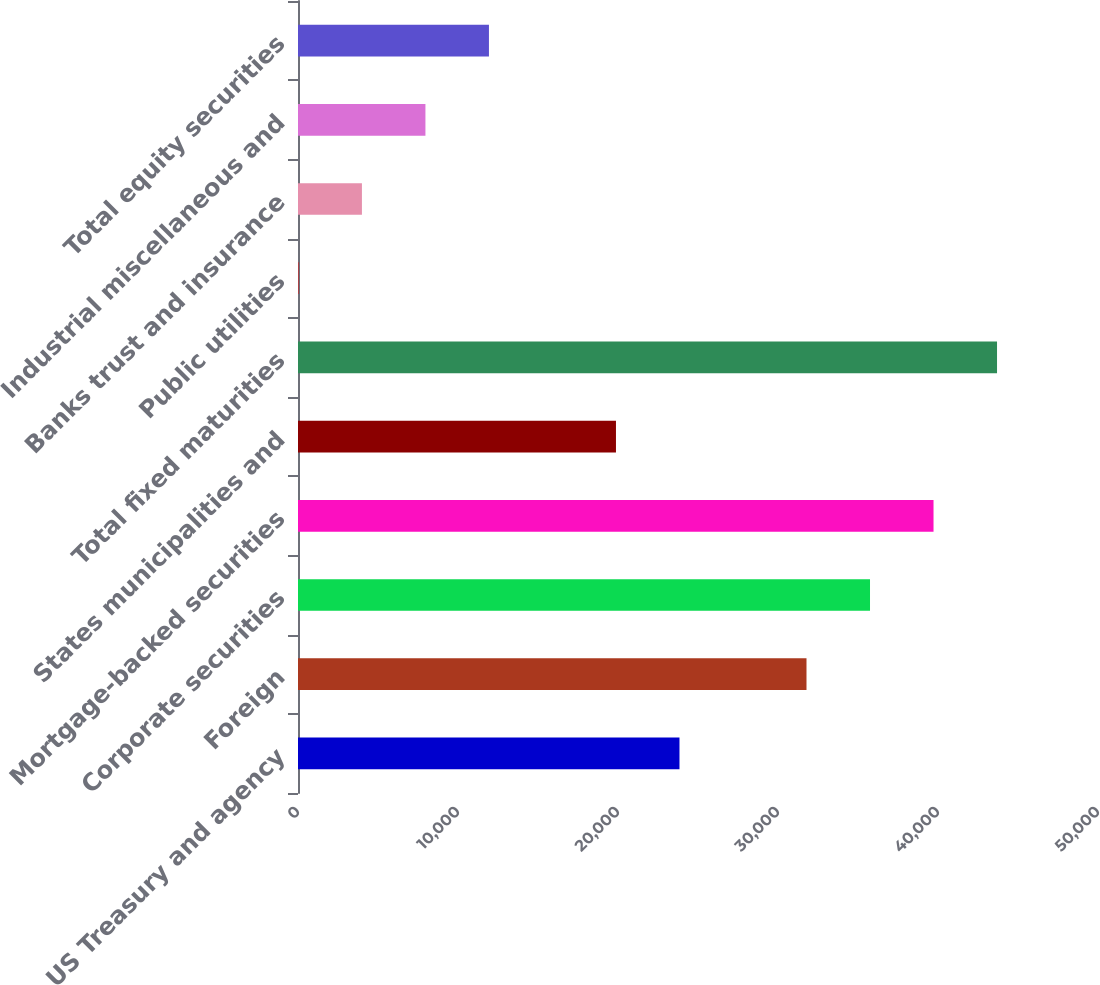Convert chart. <chart><loc_0><loc_0><loc_500><loc_500><bar_chart><fcel>US Treasury and agency<fcel>Foreign<fcel>Corporate securities<fcel>Mortgage-backed securities<fcel>States municipalities and<fcel>Total fixed maturities<fcel>Public utilities<fcel>Banks trust and insurance<fcel>Industrial miscellaneous and<fcel>Total equity securities<nl><fcel>23842.4<fcel>31781.2<fcel>35750.6<fcel>39720<fcel>19873<fcel>43689.4<fcel>26<fcel>3995.4<fcel>7964.8<fcel>11934.2<nl></chart> 